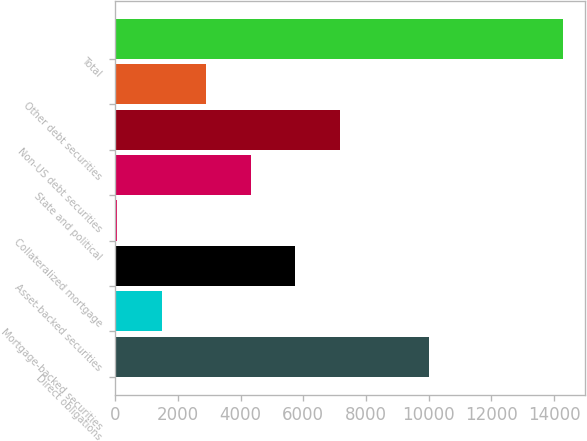<chart> <loc_0><loc_0><loc_500><loc_500><bar_chart><fcel>Direct obligations<fcel>Mortgage-backed securities<fcel>Asset-backed securities<fcel>Collateralized mortgage<fcel>State and political<fcel>Non-US debt securities<fcel>Other debt securities<fcel>Total<nl><fcel>10001<fcel>1479.5<fcel>5744<fcel>58<fcel>4322.5<fcel>7165.5<fcel>2901<fcel>14273<nl></chart> 